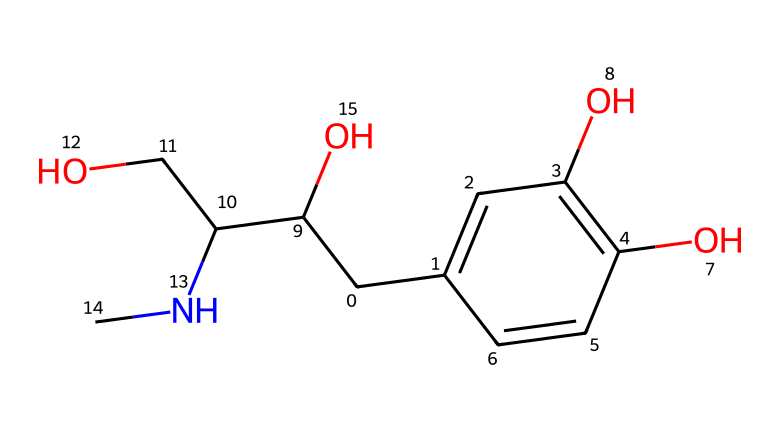What is the chemical name of this structure? The SMILES representation corresponds to a specific chemical structure. By interpreting the SMILES, we can determine that the common name for this structure is adrenaline.
Answer: adrenaline How many carbon atoms are present in this molecule? To count the carbon atoms, we analyze the SMILES string. Each 'C' represents a carbon atom. By counting, we find that there are 9 carbon atoms in total.
Answer: 9 What functional groups are present in this structure? Examining the structure shows the presence of hydroxyl groups (-OH) and an amine group (-NH). The hydroxyl groups indicate the presence of alcohol functional groups.
Answer: hydroxyl and amine How many oxygen atoms are in this molecule? The SMILES representation contains the letter 'O', which represents oxygen atoms. By counting the occurrences of 'O', we find that there are 3 oxygen atoms in the structure.
Answer: 3 What characterizes this molecule as a hormone? This molecule is classified as a hormone due to its role in the body's signaling processes. Adrenaline is known for its function in the fight or flight response.
Answer: signaling role What does the presence of the -NH (amine) group indicate about this compound? The presence of the -NH group suggests that this molecule can participate in hydrogen bonding and is likely involved in neurotransmission, which is significant for its hormonal activity.
Answer: neurotransmission involvement How does the structure relate to its physiological functions? The structure of adrenaline, with its specific functional groups, allows it to interact with adrenergic receptors, leading to various physiological effects such as increased heart rate and energy mobilization.
Answer: receptor interaction 